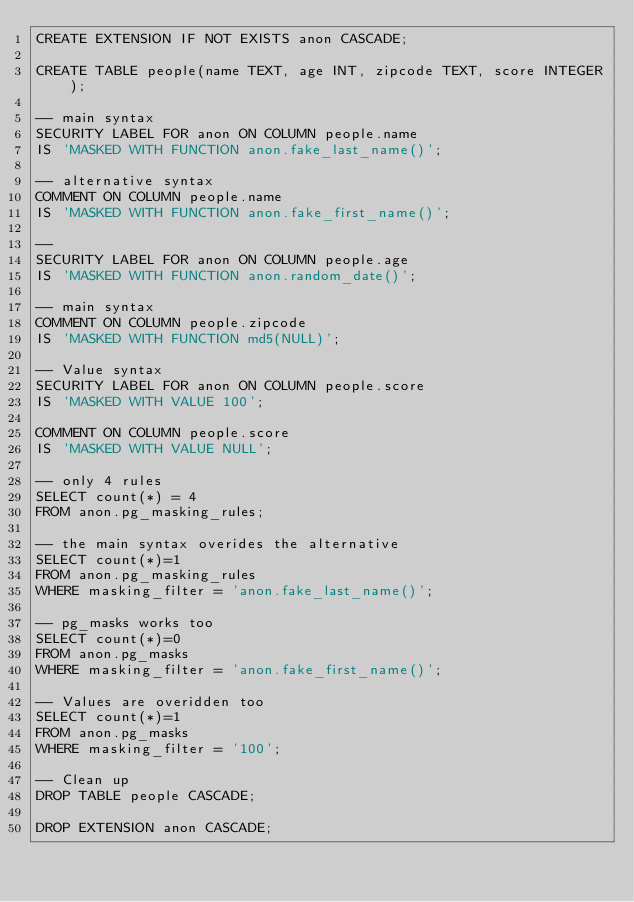<code> <loc_0><loc_0><loc_500><loc_500><_SQL_>CREATE EXTENSION IF NOT EXISTS anon CASCADE;

CREATE TABLE people(name TEXT, age INT, zipcode TEXT, score INTEGER);

-- main syntax
SECURITY LABEL FOR anon ON COLUMN people.name
IS 'MASKED WITH FUNCTION anon.fake_last_name()';

-- alternative syntax
COMMENT ON COLUMN people.name
IS 'MASKED WITH FUNCTION anon.fake_first_name()';

--
SECURITY LABEL FOR anon ON COLUMN people.age
IS 'MASKED WITH FUNCTION anon.random_date()';

-- main syntax
COMMENT ON COLUMN people.zipcode
IS 'MASKED WITH FUNCTION md5(NULL)';

-- Value syntax
SECURITY LABEL FOR anon ON COLUMN people.score
IS 'MASKED WITH VALUE 100';

COMMENT ON COLUMN people.score
IS 'MASKED WITH VALUE NULL';

-- only 4 rules
SELECT count(*) = 4
FROM anon.pg_masking_rules;

-- the main syntax overides the alternative
SELECT count(*)=1
FROM anon.pg_masking_rules
WHERE masking_filter = 'anon.fake_last_name()';

-- pg_masks works too
SELECT count(*)=0
FROM anon.pg_masks
WHERE masking_filter = 'anon.fake_first_name()';

-- Values are overidden too
SELECT count(*)=1
FROM anon.pg_masks
WHERE masking_filter = '100';

-- Clean up
DROP TABLE people CASCADE;

DROP EXTENSION anon CASCADE;
</code> 